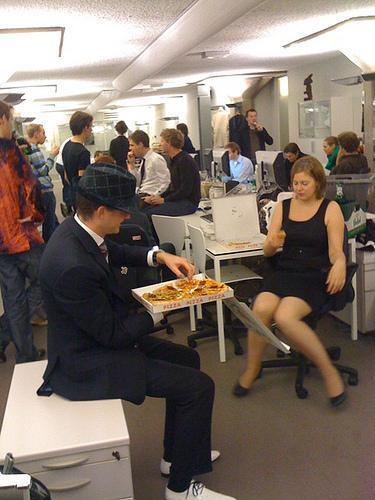How many people are there?
Give a very brief answer. 4. How many kites are there?
Give a very brief answer. 0. 